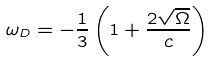<formula> <loc_0><loc_0><loc_500><loc_500>\omega _ { D } = - \frac { 1 } { 3 } \left ( 1 + \frac { 2 \sqrt { \Omega } } { c } \right )</formula> 